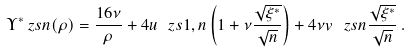<formula> <loc_0><loc_0><loc_500><loc_500>\Upsilon ^ { * } _ { \ } z s { n } ( \rho ) = \frac { 1 6 \nu } { \rho } + 4 u _ { \ } z s { 1 , n } \left ( 1 + \nu \frac { \sqrt { \xi ^ { * } } } { \sqrt { n } } \right ) + 4 \nu v _ { \ } z s { n } \frac { \sqrt { \xi ^ { * } } } { \sqrt { n } } \, .</formula> 